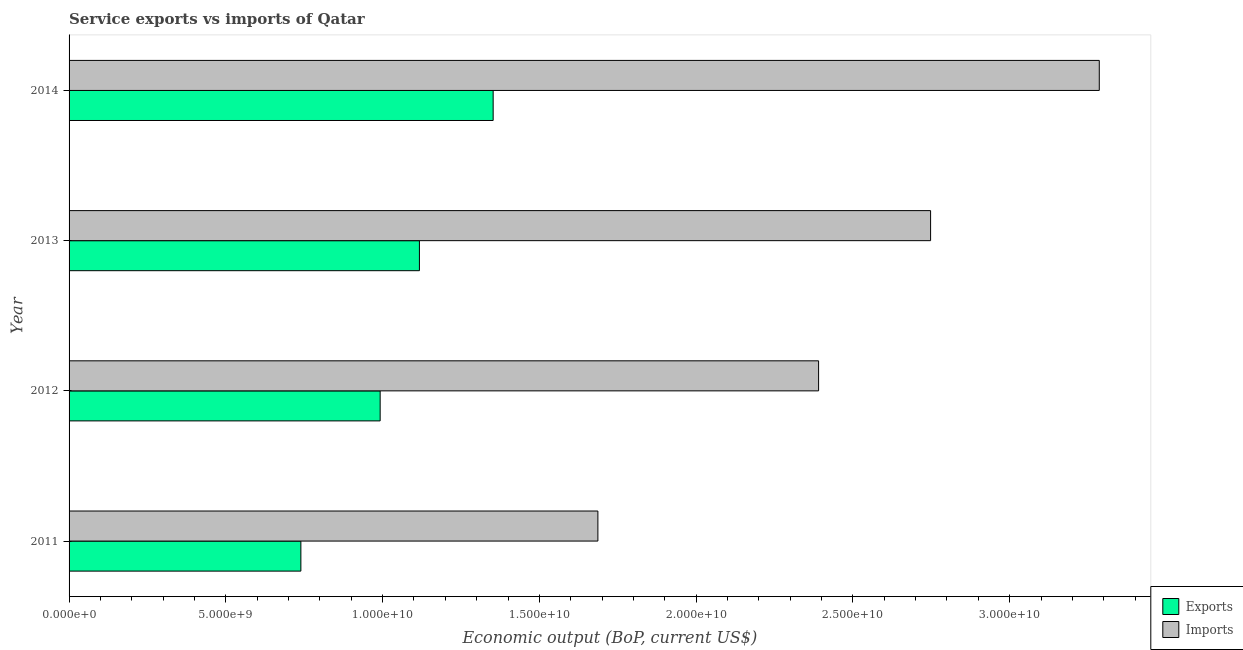How many different coloured bars are there?
Provide a succinct answer. 2. Are the number of bars per tick equal to the number of legend labels?
Your response must be concise. Yes. Are the number of bars on each tick of the Y-axis equal?
Offer a very short reply. Yes. What is the amount of service exports in 2011?
Provide a short and direct response. 7.39e+09. Across all years, what is the maximum amount of service exports?
Provide a short and direct response. 1.35e+1. Across all years, what is the minimum amount of service imports?
Your response must be concise. 1.69e+1. In which year was the amount of service imports maximum?
Offer a very short reply. 2014. In which year was the amount of service exports minimum?
Provide a short and direct response. 2011. What is the total amount of service exports in the graph?
Provide a succinct answer. 4.20e+1. What is the difference between the amount of service exports in 2012 and that in 2014?
Ensure brevity in your answer.  -3.60e+09. What is the difference between the amount of service exports in 2014 and the amount of service imports in 2012?
Make the answer very short. -1.04e+1. What is the average amount of service imports per year?
Your answer should be very brief. 2.53e+1. In the year 2013, what is the difference between the amount of service exports and amount of service imports?
Ensure brevity in your answer.  -1.63e+1. What is the ratio of the amount of service imports in 2011 to that in 2012?
Provide a short and direct response. 0.71. Is the difference between the amount of service imports in 2012 and 2013 greater than the difference between the amount of service exports in 2012 and 2013?
Your response must be concise. No. What is the difference between the highest and the second highest amount of service imports?
Your answer should be very brief. 5.38e+09. What is the difference between the highest and the lowest amount of service exports?
Give a very brief answer. 6.13e+09. In how many years, is the amount of service imports greater than the average amount of service imports taken over all years?
Give a very brief answer. 2. Is the sum of the amount of service imports in 2012 and 2013 greater than the maximum amount of service exports across all years?
Offer a very short reply. Yes. What does the 1st bar from the top in 2013 represents?
Offer a terse response. Imports. What does the 1st bar from the bottom in 2012 represents?
Keep it short and to the point. Exports. Are all the bars in the graph horizontal?
Make the answer very short. Yes. What is the difference between two consecutive major ticks on the X-axis?
Ensure brevity in your answer.  5.00e+09. Are the values on the major ticks of X-axis written in scientific E-notation?
Your answer should be very brief. Yes. Does the graph contain any zero values?
Keep it short and to the point. No. How many legend labels are there?
Provide a succinct answer. 2. What is the title of the graph?
Offer a very short reply. Service exports vs imports of Qatar. What is the label or title of the X-axis?
Ensure brevity in your answer.  Economic output (BoP, current US$). What is the Economic output (BoP, current US$) in Exports in 2011?
Your response must be concise. 7.39e+09. What is the Economic output (BoP, current US$) in Imports in 2011?
Offer a very short reply. 1.69e+1. What is the Economic output (BoP, current US$) of Exports in 2012?
Ensure brevity in your answer.  9.92e+09. What is the Economic output (BoP, current US$) in Imports in 2012?
Make the answer very short. 2.39e+1. What is the Economic output (BoP, current US$) of Exports in 2013?
Make the answer very short. 1.12e+1. What is the Economic output (BoP, current US$) of Imports in 2013?
Offer a very short reply. 2.75e+1. What is the Economic output (BoP, current US$) of Exports in 2014?
Your response must be concise. 1.35e+1. What is the Economic output (BoP, current US$) in Imports in 2014?
Offer a very short reply. 3.29e+1. Across all years, what is the maximum Economic output (BoP, current US$) in Exports?
Offer a terse response. 1.35e+1. Across all years, what is the maximum Economic output (BoP, current US$) in Imports?
Offer a very short reply. 3.29e+1. Across all years, what is the minimum Economic output (BoP, current US$) in Exports?
Your answer should be very brief. 7.39e+09. Across all years, what is the minimum Economic output (BoP, current US$) in Imports?
Offer a terse response. 1.69e+1. What is the total Economic output (BoP, current US$) in Exports in the graph?
Offer a terse response. 4.20e+1. What is the total Economic output (BoP, current US$) in Imports in the graph?
Ensure brevity in your answer.  1.01e+11. What is the difference between the Economic output (BoP, current US$) in Exports in 2011 and that in 2012?
Your answer should be very brief. -2.53e+09. What is the difference between the Economic output (BoP, current US$) of Imports in 2011 and that in 2012?
Ensure brevity in your answer.  -7.04e+09. What is the difference between the Economic output (BoP, current US$) of Exports in 2011 and that in 2013?
Make the answer very short. -3.78e+09. What is the difference between the Economic output (BoP, current US$) of Imports in 2011 and that in 2013?
Keep it short and to the point. -1.06e+1. What is the difference between the Economic output (BoP, current US$) in Exports in 2011 and that in 2014?
Keep it short and to the point. -6.13e+09. What is the difference between the Economic output (BoP, current US$) of Imports in 2011 and that in 2014?
Your response must be concise. -1.60e+1. What is the difference between the Economic output (BoP, current US$) in Exports in 2012 and that in 2013?
Your response must be concise. -1.25e+09. What is the difference between the Economic output (BoP, current US$) of Imports in 2012 and that in 2013?
Provide a succinct answer. -3.57e+09. What is the difference between the Economic output (BoP, current US$) of Exports in 2012 and that in 2014?
Your answer should be compact. -3.60e+09. What is the difference between the Economic output (BoP, current US$) in Imports in 2012 and that in 2014?
Your response must be concise. -8.95e+09. What is the difference between the Economic output (BoP, current US$) in Exports in 2013 and that in 2014?
Ensure brevity in your answer.  -2.35e+09. What is the difference between the Economic output (BoP, current US$) of Imports in 2013 and that in 2014?
Your response must be concise. -5.38e+09. What is the difference between the Economic output (BoP, current US$) in Exports in 2011 and the Economic output (BoP, current US$) in Imports in 2012?
Provide a succinct answer. -1.65e+1. What is the difference between the Economic output (BoP, current US$) in Exports in 2011 and the Economic output (BoP, current US$) in Imports in 2013?
Your answer should be very brief. -2.01e+1. What is the difference between the Economic output (BoP, current US$) of Exports in 2011 and the Economic output (BoP, current US$) of Imports in 2014?
Provide a succinct answer. -2.55e+1. What is the difference between the Economic output (BoP, current US$) in Exports in 2012 and the Economic output (BoP, current US$) in Imports in 2013?
Provide a succinct answer. -1.76e+1. What is the difference between the Economic output (BoP, current US$) in Exports in 2012 and the Economic output (BoP, current US$) in Imports in 2014?
Offer a very short reply. -2.29e+1. What is the difference between the Economic output (BoP, current US$) in Exports in 2013 and the Economic output (BoP, current US$) in Imports in 2014?
Your response must be concise. -2.17e+1. What is the average Economic output (BoP, current US$) of Exports per year?
Ensure brevity in your answer.  1.05e+1. What is the average Economic output (BoP, current US$) of Imports per year?
Ensure brevity in your answer.  2.53e+1. In the year 2011, what is the difference between the Economic output (BoP, current US$) of Exports and Economic output (BoP, current US$) of Imports?
Provide a succinct answer. -9.47e+09. In the year 2012, what is the difference between the Economic output (BoP, current US$) in Exports and Economic output (BoP, current US$) in Imports?
Your answer should be very brief. -1.40e+1. In the year 2013, what is the difference between the Economic output (BoP, current US$) in Exports and Economic output (BoP, current US$) in Imports?
Provide a short and direct response. -1.63e+1. In the year 2014, what is the difference between the Economic output (BoP, current US$) in Exports and Economic output (BoP, current US$) in Imports?
Provide a short and direct response. -1.93e+1. What is the ratio of the Economic output (BoP, current US$) of Exports in 2011 to that in 2012?
Your response must be concise. 0.75. What is the ratio of the Economic output (BoP, current US$) of Imports in 2011 to that in 2012?
Give a very brief answer. 0.71. What is the ratio of the Economic output (BoP, current US$) in Exports in 2011 to that in 2013?
Give a very brief answer. 0.66. What is the ratio of the Economic output (BoP, current US$) of Imports in 2011 to that in 2013?
Provide a short and direct response. 0.61. What is the ratio of the Economic output (BoP, current US$) in Exports in 2011 to that in 2014?
Give a very brief answer. 0.55. What is the ratio of the Economic output (BoP, current US$) in Imports in 2011 to that in 2014?
Your response must be concise. 0.51. What is the ratio of the Economic output (BoP, current US$) in Exports in 2012 to that in 2013?
Keep it short and to the point. 0.89. What is the ratio of the Economic output (BoP, current US$) in Imports in 2012 to that in 2013?
Ensure brevity in your answer.  0.87. What is the ratio of the Economic output (BoP, current US$) of Exports in 2012 to that in 2014?
Your answer should be compact. 0.73. What is the ratio of the Economic output (BoP, current US$) of Imports in 2012 to that in 2014?
Keep it short and to the point. 0.73. What is the ratio of the Economic output (BoP, current US$) of Exports in 2013 to that in 2014?
Your answer should be compact. 0.83. What is the ratio of the Economic output (BoP, current US$) of Imports in 2013 to that in 2014?
Offer a terse response. 0.84. What is the difference between the highest and the second highest Economic output (BoP, current US$) of Exports?
Ensure brevity in your answer.  2.35e+09. What is the difference between the highest and the second highest Economic output (BoP, current US$) of Imports?
Your response must be concise. 5.38e+09. What is the difference between the highest and the lowest Economic output (BoP, current US$) of Exports?
Ensure brevity in your answer.  6.13e+09. What is the difference between the highest and the lowest Economic output (BoP, current US$) in Imports?
Offer a very short reply. 1.60e+1. 